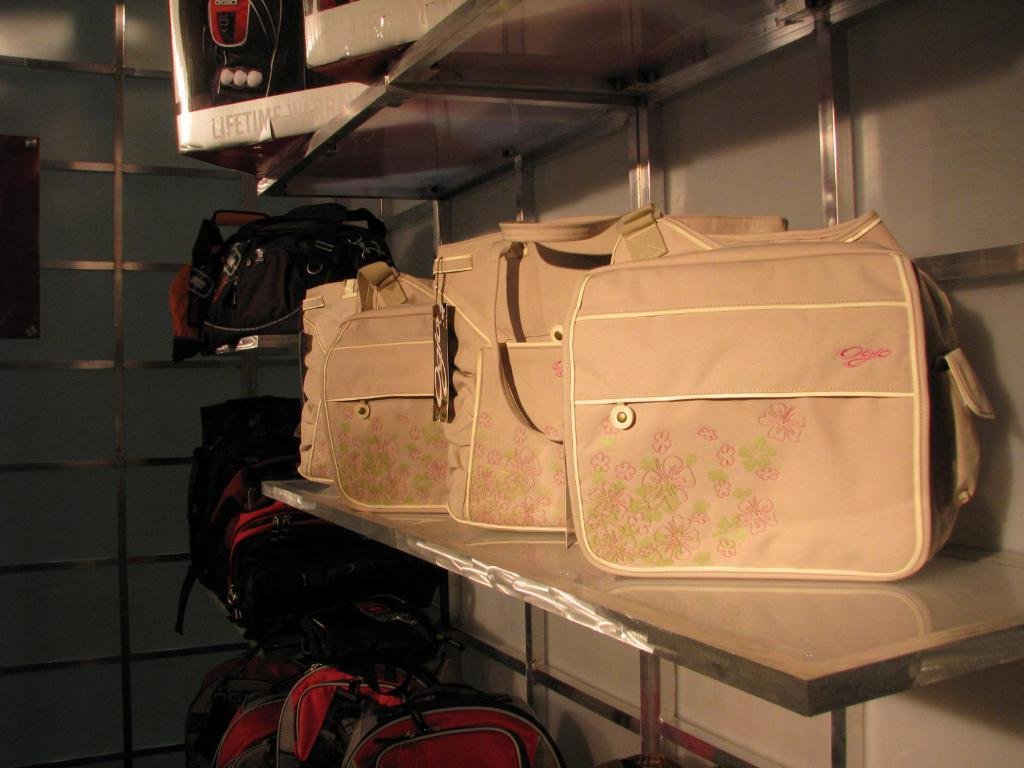What objects are present in the image? There are bags in the image. Can you describe the appearance of the bags? The bags are cream and black in color. Where are the bags located in the image? The bags are on racks. What can be seen in the background of the image? There is a railing visible in the background of the image. How many kittens are sitting on the bags in the image? There are no kittens present in the image; it only features bags on racks. 